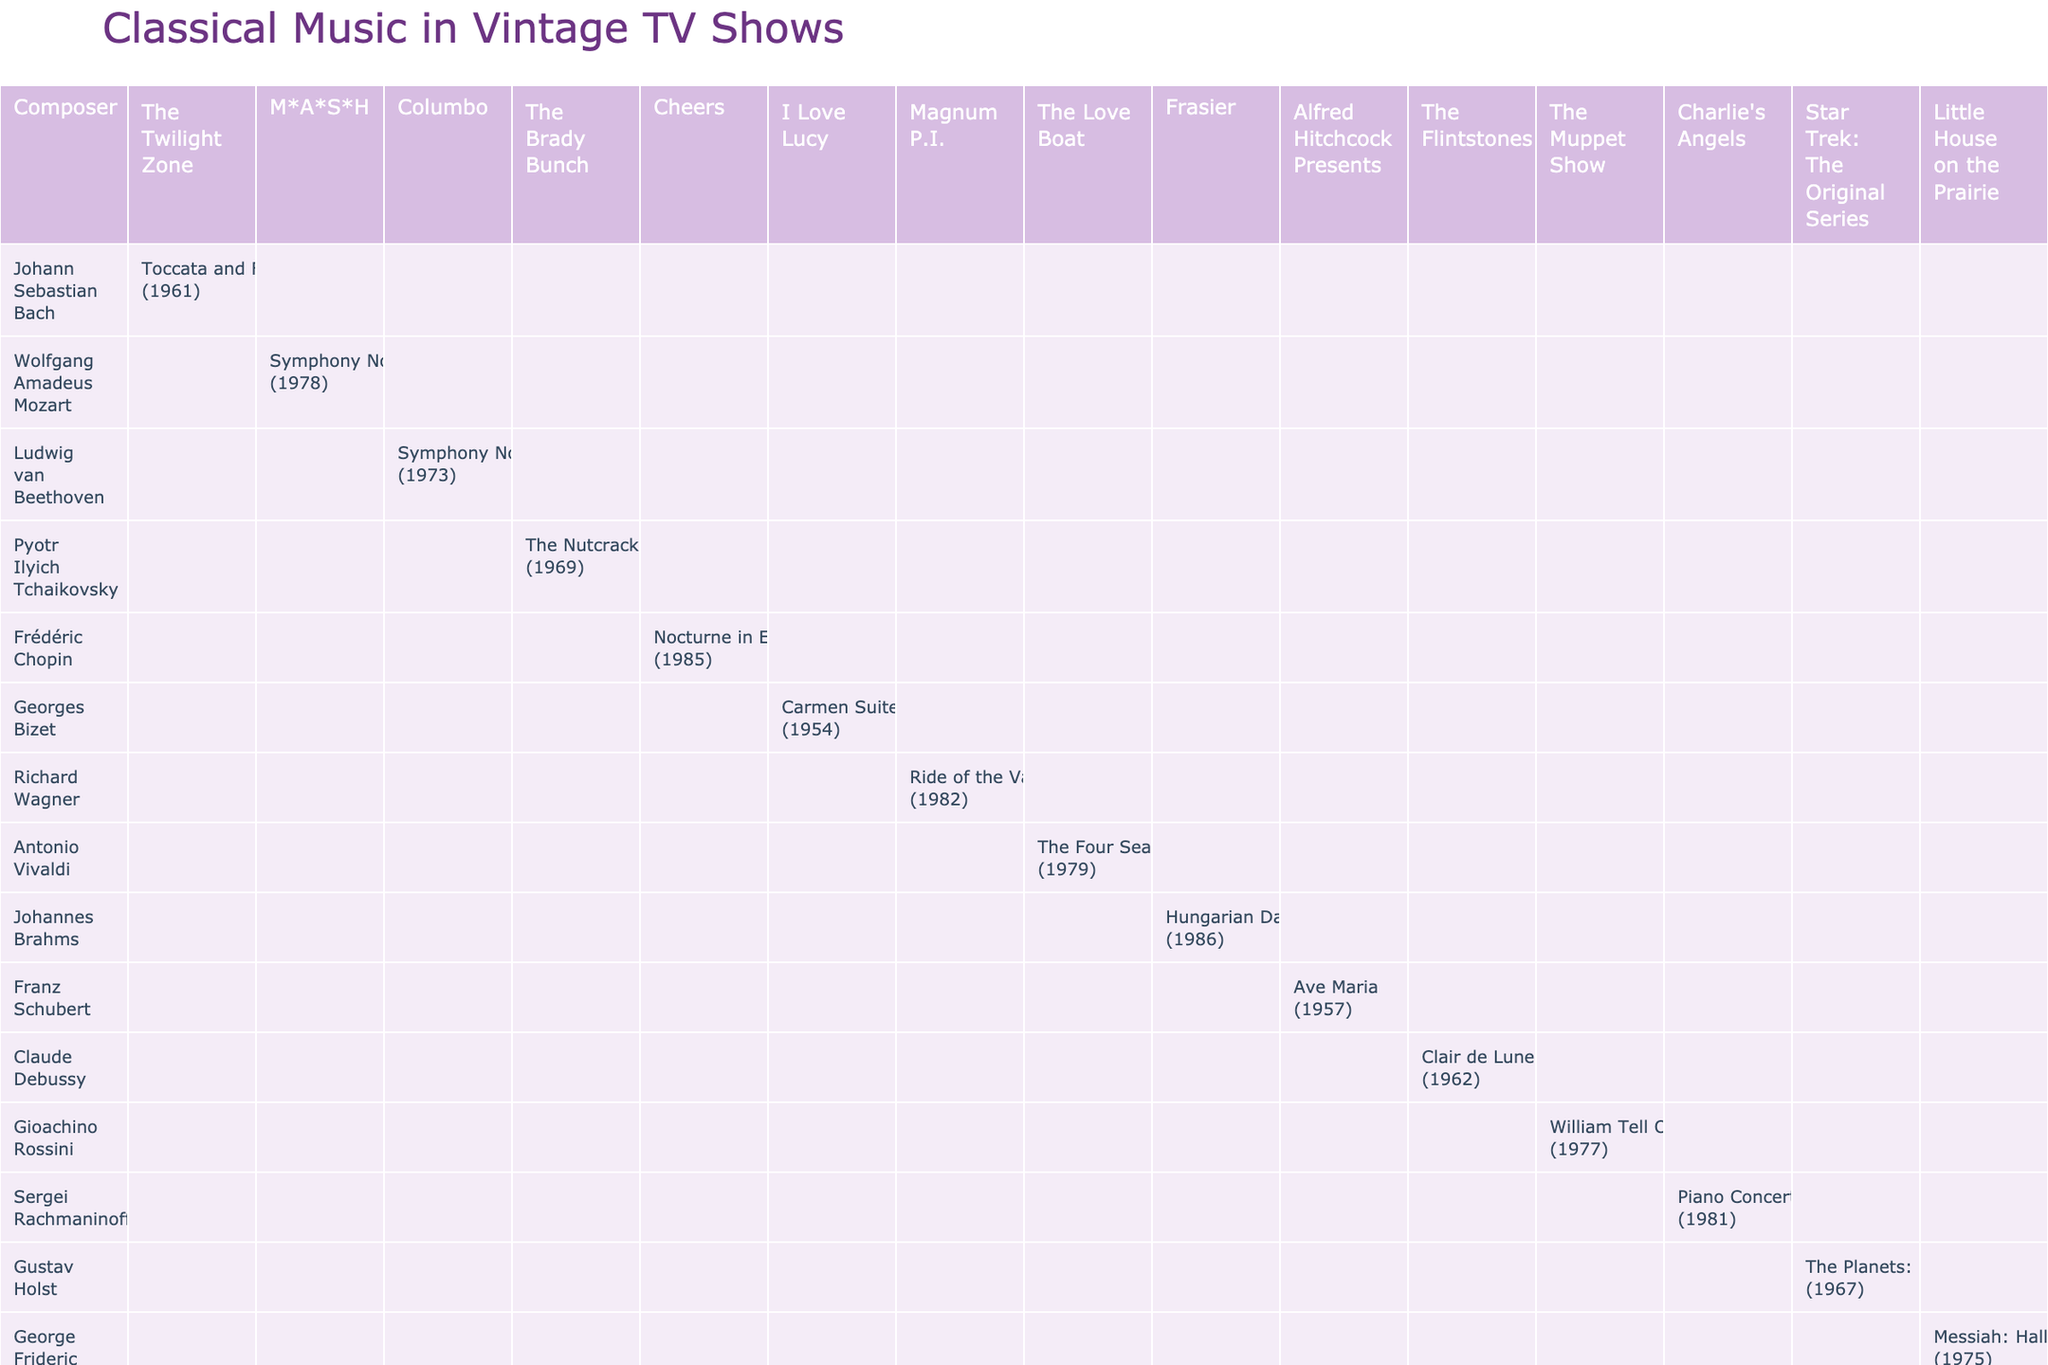What composer was featured in the episode "The Voice of Christmas"? The episode "The Voice of Christmas" is from "The Brady Bunch." By looking at the table, I can see that Pyotr Ilyich Tchaikovsky is listed next to this TV show.
Answer: Pyotr Ilyich Tchaikovsky Which piece by Beethoven was featured in "Columbo"? The table shows that the piece featured in "Columbo" is "Symphony No. 5" by Ludwig van Beethoven, listed alongside the year 1973.
Answer: Symphony No. 5 How many different TV shows feature works by Mozart? In the table, Wolfgang Amadeus Mozart is mentioned only once in connection with the TV show "M*A*S*H". Thus, there is only one unique TV show featuring his music.
Answer: 1 True or False: The "Ave Maria" by Schubert was featured in a show from the 1980s. The table indicates that "Ave Maria" is associated with "Alfred Hitchcock Presents" from 1957, which means it was not featured in the 1980s.
Answer: False What is the difference in the years between the piece by Rachmaninoff in "Charlie's Angels" and the piece by Debussy in "The Flintstones"? Rachmaninoff's piece was featured in 1981, and Debussy's in 1962. The difference is 1981 - 1962 = 19 years.
Answer: 19 Which composer had their work featured in the earliest episode listed in the table? Looking through the table, "The Opera" from "I Love Lucy" features Georges Bizet's work from 1954, which is the earliest year mentioned in the table.
Answer: Georges Bizet How many composers are featured in "Frasier"? The table shows that there is one composer featured in "Frasier," which is Johannes Brahms, with Hungarian Dance No. 5 noted.
Answer: 1 What is the featured piece by Handel, and in which show did it appear? The table lists "Messiah: Hallelujah Chorus" by George Frideric Handel, which appears in the show "Little House on the Prairie."
Answer: Messiah: Hallelujah Chorus, Little House on the Prairie Which two composers had their pieces featured in the same year, 1979? By scanning the table, Antonio Vivaldi in "The Love Boat" and Sergei Rachmaninoff in "Charlie's Angels" are both linked to the year 1979 within the document.
Answer: Antonio Vivaldi, Sergei Rachmaninoff Identify the last composer mentioned in the table. The table lists the composers in alphabetical order, and the last composer is Richard Wagner.
Answer: Richard Wagner What year did "The Howling Man" episode of "The Twilight Zone" air? The table indicates that "The Howling Man" was featured in the year 1961 alongside Johann Sebastian Bach.
Answer: 1961 